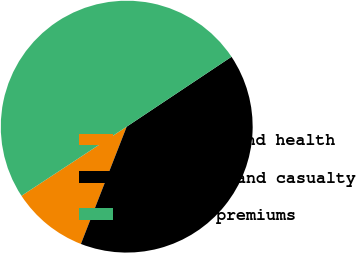Convert chart to OTSL. <chart><loc_0><loc_0><loc_500><loc_500><pie_chart><fcel>Accident and health<fcel>Property and casualty<fcel>Earned premiums<nl><fcel>9.82%<fcel>40.29%<fcel>49.9%<nl></chart> 